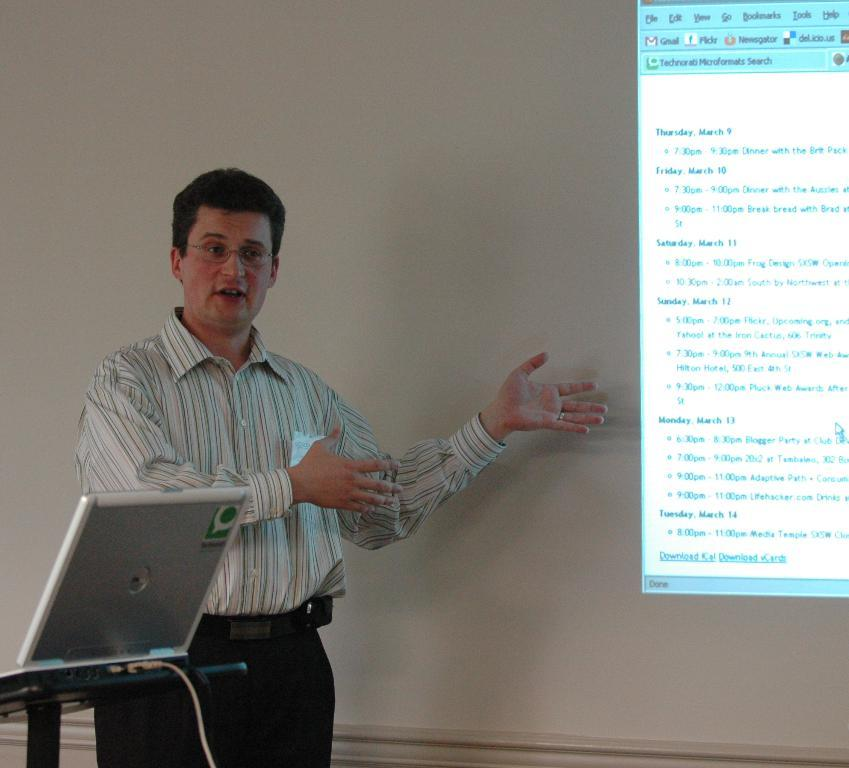What is the main subject in the center of the image? There is a person standing in the center of the image. What electronic device is located on the left side of the image? There is a laptop on the left side of the image. What can be seen in the background of the image? There is a screen visible in the background of the image. What type of religious symbol can be seen on the person's pocket in the image? There is no religious symbol or pocket visible on the person in the image. What is the engine used for in the image? There is no engine present in the image. 